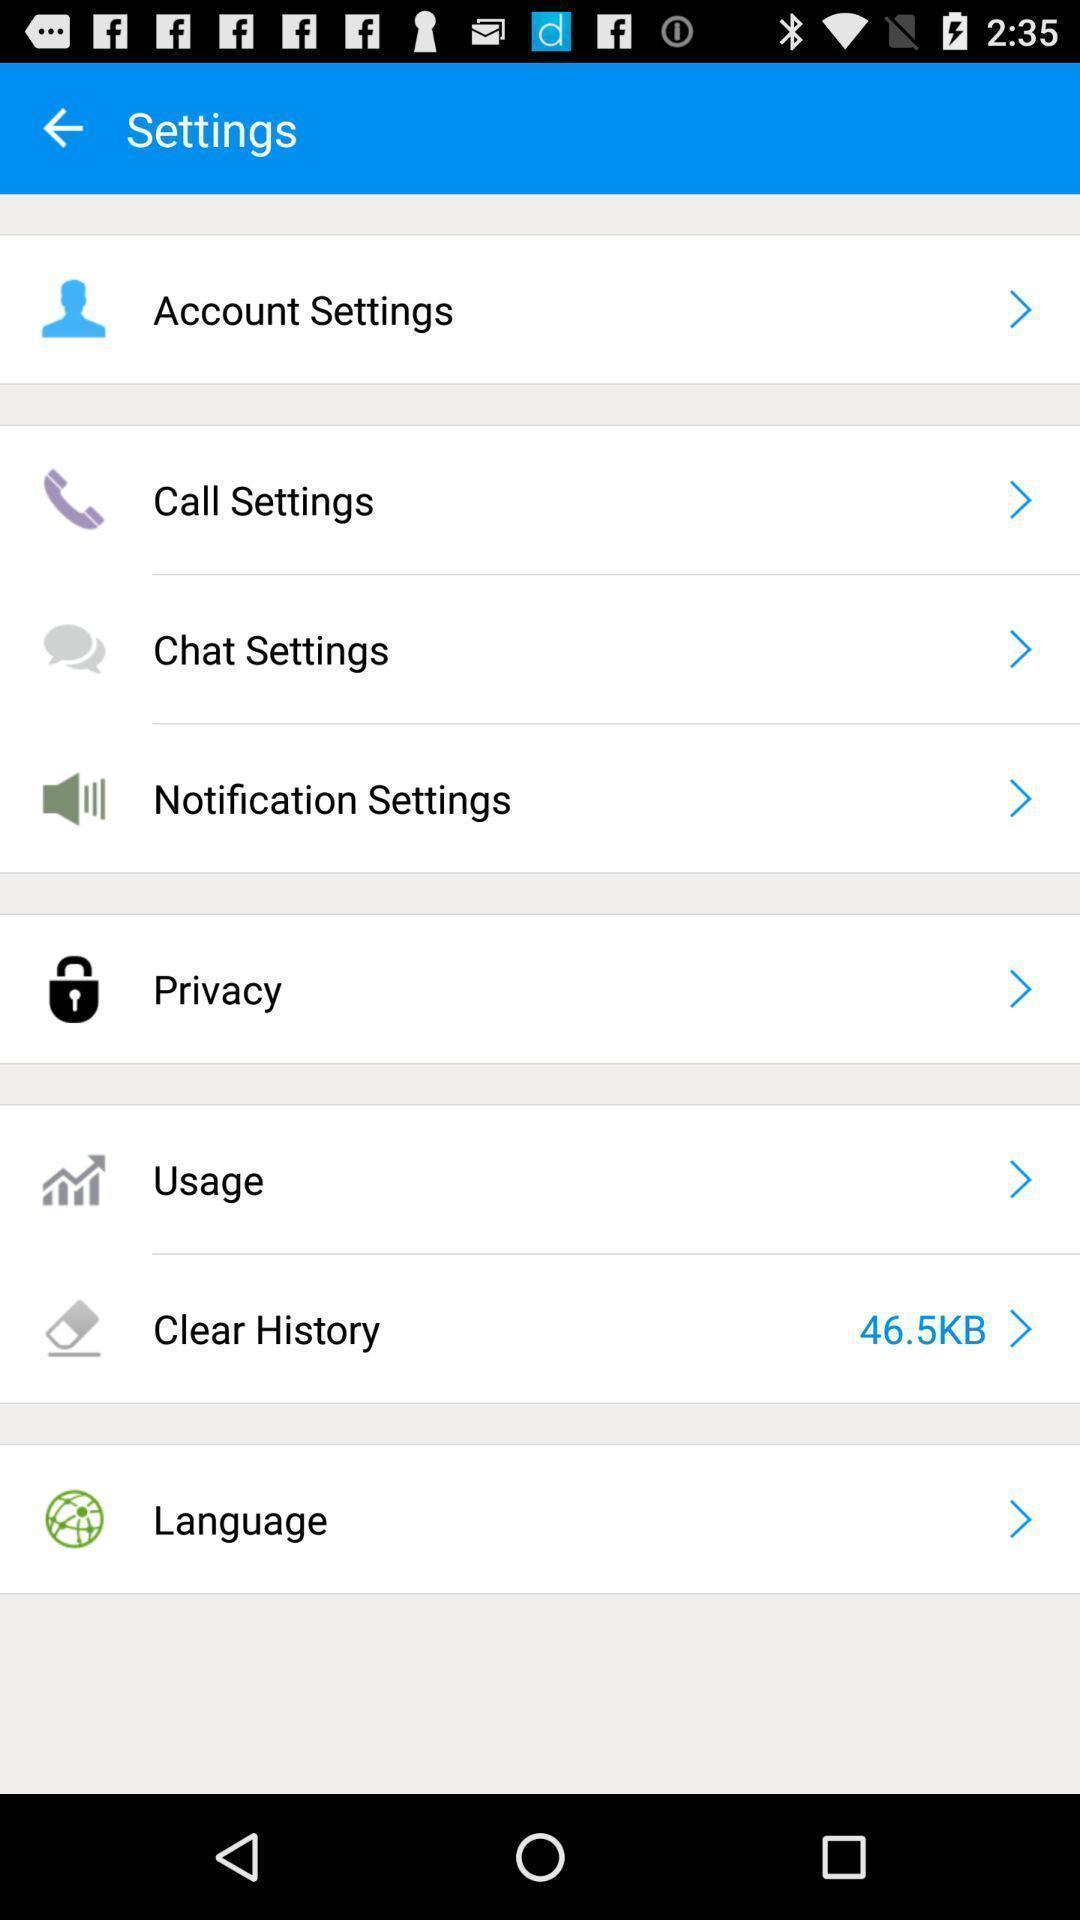Describe the visual elements of this screenshot. Settings page with various options. 